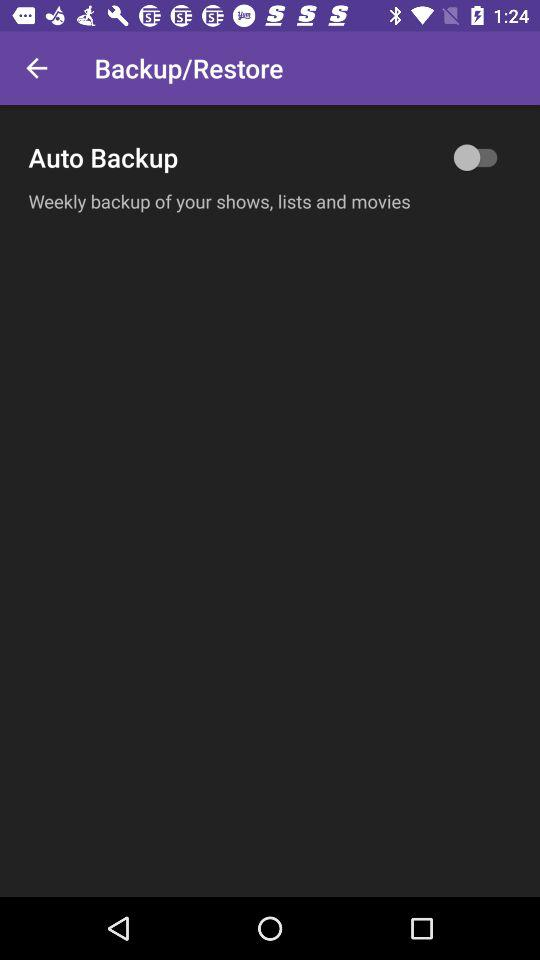What is the use of auto backup? The use is "shows, lists and movies". 